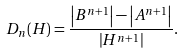Convert formula to latex. <formula><loc_0><loc_0><loc_500><loc_500>D _ { n } ( H ) = \frac { \left | B ^ { n + 1 } \right | - \left | A ^ { n + 1 } \right | } { \left | H ^ { n + 1 } \right | } .</formula> 